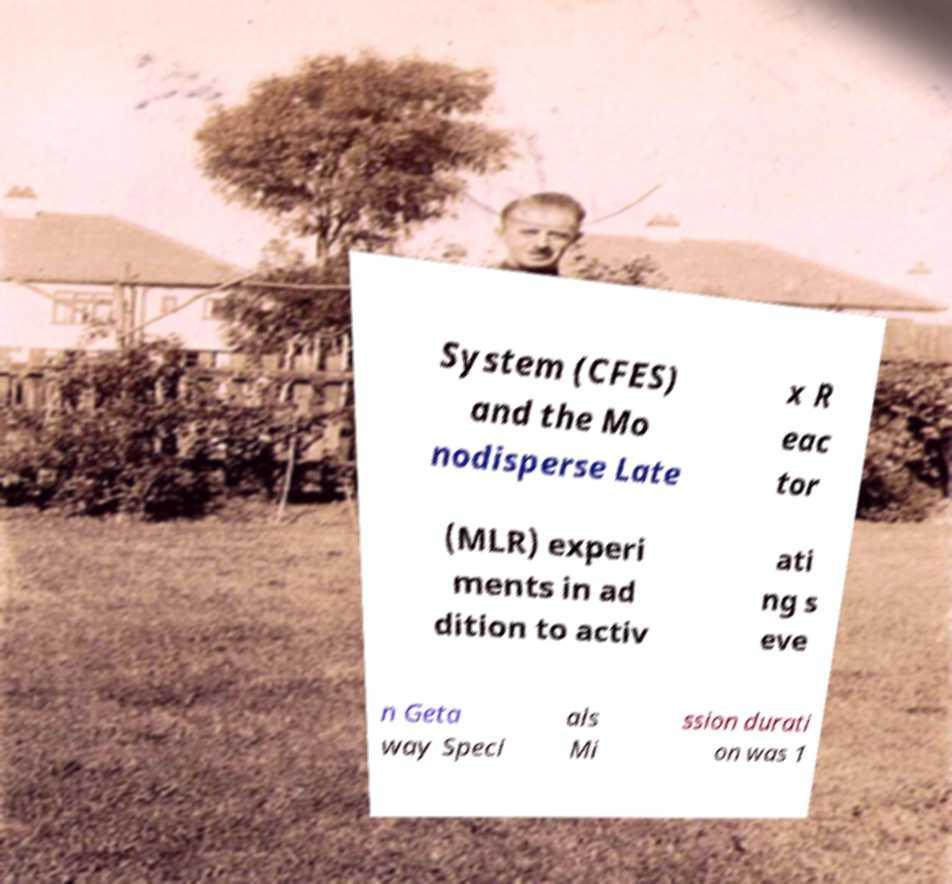Please read and relay the text visible in this image. What does it say? System (CFES) and the Mo nodisperse Late x R eac tor (MLR) experi ments in ad dition to activ ati ng s eve n Geta way Speci als Mi ssion durati on was 1 